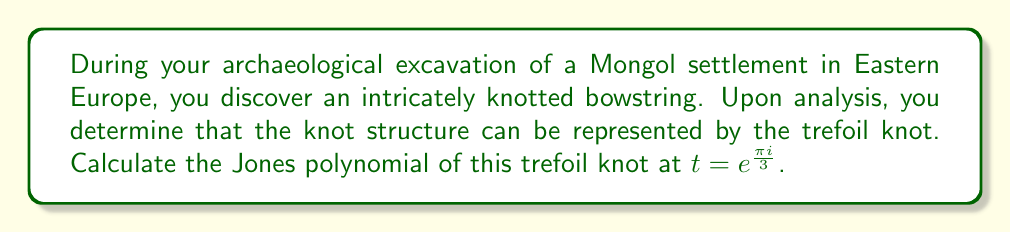Provide a solution to this math problem. To solve this problem, we'll follow these steps:

1) The Jones polynomial for a trefoil knot is given by:

   $$V(t) = t + t^3 - t^4$$

2) We need to evaluate this polynomial at $t = e^{\frac{\pi i}{3}}$. Let's substitute this value:

   $$V(e^{\frac{\pi i}{3}}) = e^{\frac{\pi i}{3}} + (e^{\frac{\pi i}{3}})^3 - (e^{\frac{\pi i}{3}})^4$$

3) Simplify the exponents:

   $$V(e^{\frac{\pi i}{3}}) = e^{\frac{\pi i}{3}} + e^{\pi i} - e^{\frac{4\pi i}{3}}$$

4) Recall Euler's formula: $e^{ix} = \cos x + i \sin x$. Apply this to each term:

   $$V(e^{\frac{\pi i}{3}}) = (\frac{1}{2} + i\frac{\sqrt{3}}{2}) + (-1) - (-\frac{1}{2} + i\frac{\sqrt{3}}{2})$$

5) Simplify:

   $$V(e^{\frac{\pi i}{3}}) = (\frac{1}{2} + i\frac{\sqrt{3}}{2}) - 1 + \frac{1}{2} - i\frac{\sqrt{3}}{2}$$

6) Combine like terms:

   $$V(e^{\frac{\pi i}{3}}) = 0$$

Therefore, the Jones polynomial of the trefoil knot evaluated at $t = e^{\frac{\pi i}{3}}$ is 0.
Answer: 0 